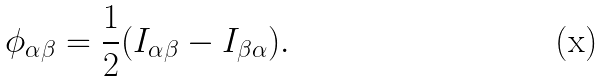<formula> <loc_0><loc_0><loc_500><loc_500>\phi _ { \alpha \beta } = \frac { 1 } { 2 } ( I _ { \alpha \beta } - I _ { \beta \alpha } ) .</formula> 